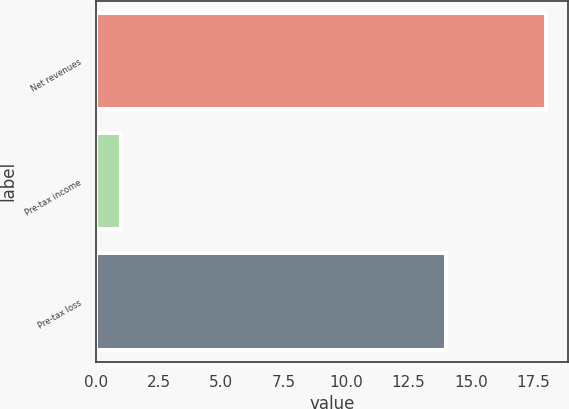Convert chart. <chart><loc_0><loc_0><loc_500><loc_500><bar_chart><fcel>Net revenues<fcel>Pre-tax income<fcel>Pre-tax loss<nl><fcel>18<fcel>1<fcel>14<nl></chart> 